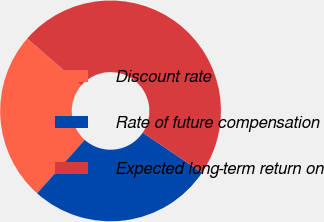Convert chart to OTSL. <chart><loc_0><loc_0><loc_500><loc_500><pie_chart><fcel>Discount rate<fcel>Rate of future compensation<fcel>Expected long-term return on<nl><fcel>24.8%<fcel>27.15%<fcel>48.05%<nl></chart> 